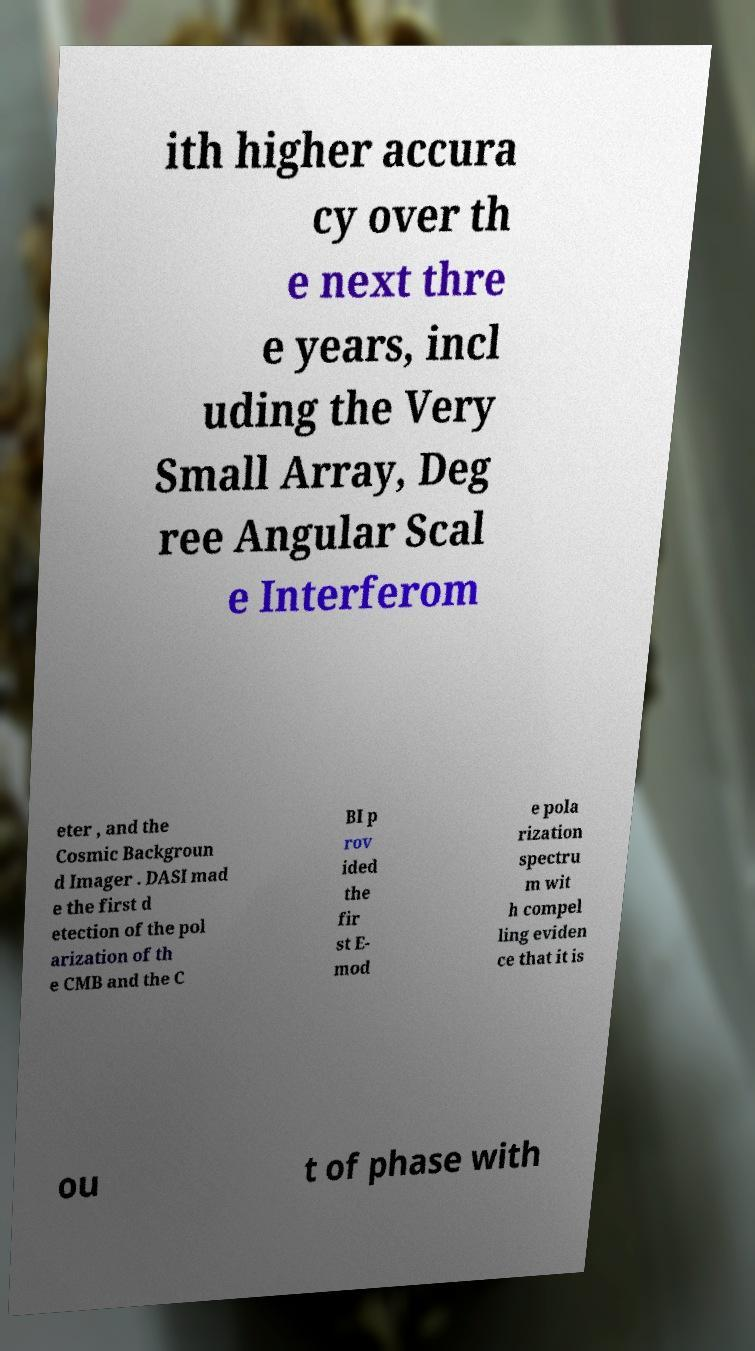I need the written content from this picture converted into text. Can you do that? ith higher accura cy over th e next thre e years, incl uding the Very Small Array, Deg ree Angular Scal e Interferom eter , and the Cosmic Backgroun d Imager . DASI mad e the first d etection of the pol arization of th e CMB and the C BI p rov ided the fir st E- mod e pola rization spectru m wit h compel ling eviden ce that it is ou t of phase with 